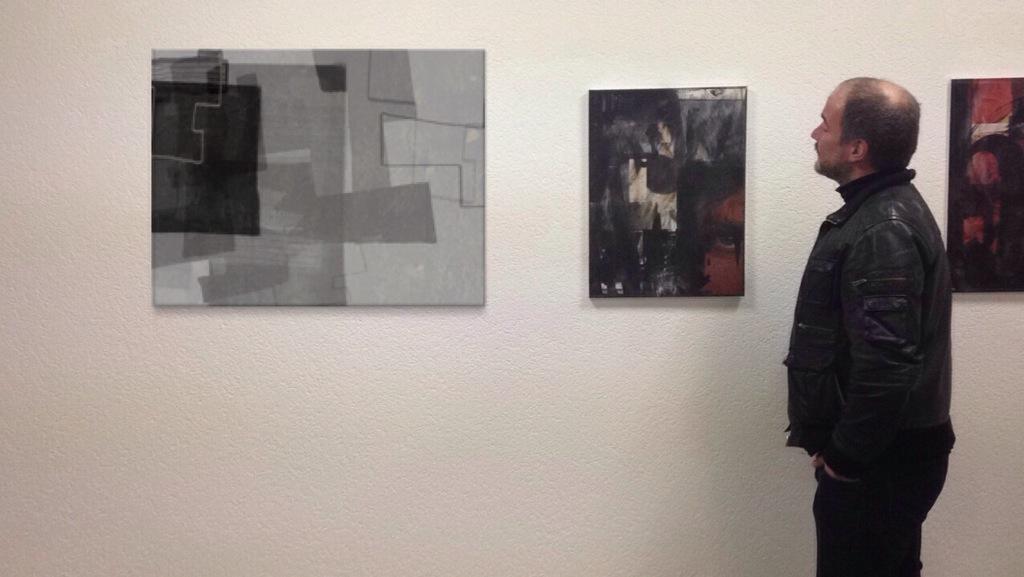How would you summarize this image in a sentence or two? In the picture I can see a man on the right side. He is wearing a black color jacket and he is looking at a photo frame which is on the wall. In the picture I can see the photo frames on the wall. 